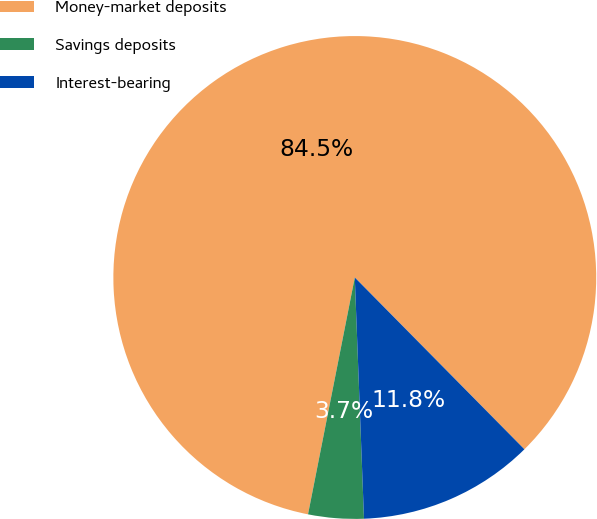Convert chart to OTSL. <chart><loc_0><loc_0><loc_500><loc_500><pie_chart><fcel>Money-market deposits<fcel>Savings deposits<fcel>Interest-bearing<nl><fcel>84.5%<fcel>3.71%<fcel>11.79%<nl></chart> 